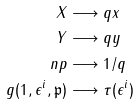<formula> <loc_0><loc_0><loc_500><loc_500>X & \longrightarrow q x \\ Y & \longrightarrow q y \\ \ n p & \longrightarrow 1 / q \\ g ( 1 , \epsilon ^ { i } , \mathfrak { p } ) & \longrightarrow \tau ( \epsilon ^ { i } )</formula> 